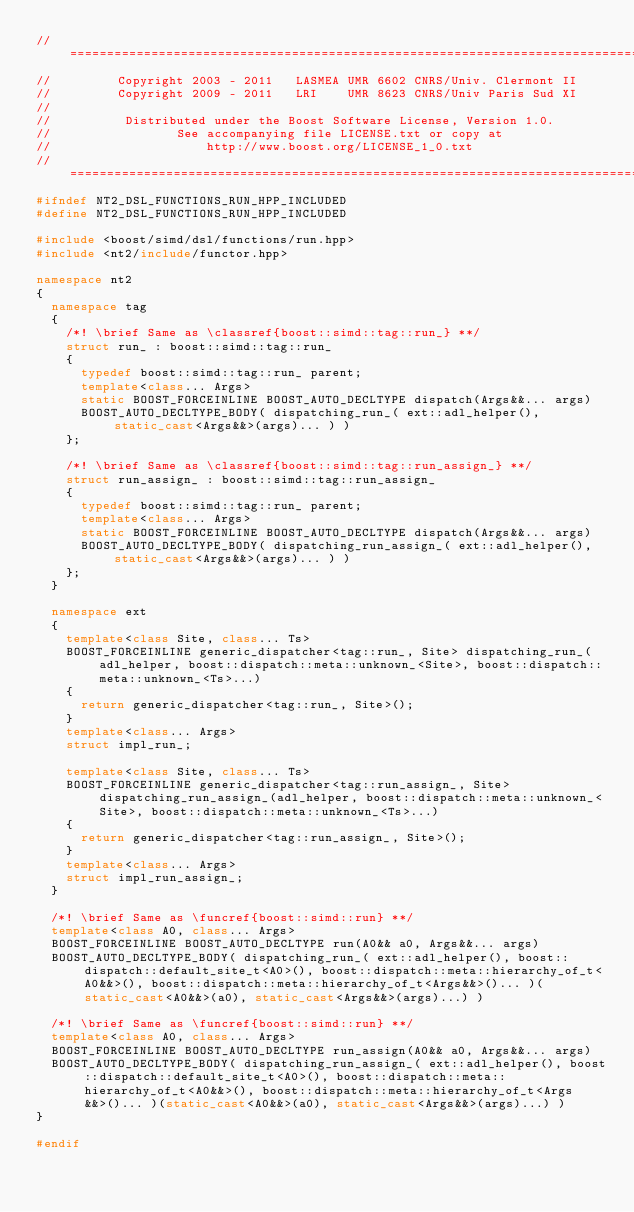<code> <loc_0><loc_0><loc_500><loc_500><_C++_>//==============================================================================
//         Copyright 2003 - 2011   LASMEA UMR 6602 CNRS/Univ. Clermont II
//         Copyright 2009 - 2011   LRI    UMR 8623 CNRS/Univ Paris Sud XI
//
//          Distributed under the Boost Software License, Version 1.0.
//                 See accompanying file LICENSE.txt or copy at
//                     http://www.boost.org/LICENSE_1_0.txt
//==============================================================================
#ifndef NT2_DSL_FUNCTIONS_RUN_HPP_INCLUDED
#define NT2_DSL_FUNCTIONS_RUN_HPP_INCLUDED

#include <boost/simd/dsl/functions/run.hpp>
#include <nt2/include/functor.hpp>

namespace nt2
{
  namespace tag
  {
    /*! \brief Same as \classref{boost::simd::tag::run_} **/
    struct run_ : boost::simd::tag::run_
    {
      typedef boost::simd::tag::run_ parent;
      template<class... Args>
      static BOOST_FORCEINLINE BOOST_AUTO_DECLTYPE dispatch(Args&&... args)
      BOOST_AUTO_DECLTYPE_BODY( dispatching_run_( ext::adl_helper(), static_cast<Args&&>(args)... ) )
    };

    /*! \brief Same as \classref{boost::simd::tag::run_assign_} **/
    struct run_assign_ : boost::simd::tag::run_assign_
    {
      typedef boost::simd::tag::run_ parent;
      template<class... Args>
      static BOOST_FORCEINLINE BOOST_AUTO_DECLTYPE dispatch(Args&&... args)
      BOOST_AUTO_DECLTYPE_BODY( dispatching_run_assign_( ext::adl_helper(), static_cast<Args&&>(args)... ) )
    };
  }

  namespace ext
  {
    template<class Site, class... Ts>
    BOOST_FORCEINLINE generic_dispatcher<tag::run_, Site> dispatching_run_(adl_helper, boost::dispatch::meta::unknown_<Site>, boost::dispatch::meta::unknown_<Ts>...)
    {
      return generic_dispatcher<tag::run_, Site>();
    }
    template<class... Args>
    struct impl_run_;

    template<class Site, class... Ts>
    BOOST_FORCEINLINE generic_dispatcher<tag::run_assign_, Site> dispatching_run_assign_(adl_helper, boost::dispatch::meta::unknown_<Site>, boost::dispatch::meta::unknown_<Ts>...)
    {
      return generic_dispatcher<tag::run_assign_, Site>();
    }
    template<class... Args>
    struct impl_run_assign_;
  }

  /*! \brief Same as \funcref{boost::simd::run} **/
  template<class A0, class... Args>
  BOOST_FORCEINLINE BOOST_AUTO_DECLTYPE run(A0&& a0, Args&&... args)
  BOOST_AUTO_DECLTYPE_BODY( dispatching_run_( ext::adl_helper(), boost::dispatch::default_site_t<A0>(), boost::dispatch::meta::hierarchy_of_t<A0&&>(), boost::dispatch::meta::hierarchy_of_t<Args&&>()... )(static_cast<A0&&>(a0), static_cast<Args&&>(args)...) )

  /*! \brief Same as \funcref{boost::simd::run} **/
  template<class A0, class... Args>
  BOOST_FORCEINLINE BOOST_AUTO_DECLTYPE run_assign(A0&& a0, Args&&... args)
  BOOST_AUTO_DECLTYPE_BODY( dispatching_run_assign_( ext::adl_helper(), boost::dispatch::default_site_t<A0>(), boost::dispatch::meta::hierarchy_of_t<A0&&>(), boost::dispatch::meta::hierarchy_of_t<Args&&>()... )(static_cast<A0&&>(a0), static_cast<Args&&>(args)...) )
}

#endif
</code> 